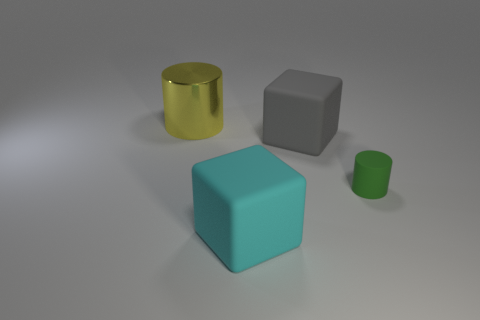Are any large gray rubber objects visible?
Your response must be concise. Yes. Do the large metallic object and the big object on the right side of the cyan object have the same shape?
Offer a very short reply. No. What color is the large matte block behind the block that is in front of the cylinder that is in front of the big cylinder?
Give a very brief answer. Gray. Are there any large yellow things in front of the gray block?
Your answer should be very brief. No. Is there another big thing made of the same material as the big gray thing?
Your answer should be compact. Yes. The metallic object is what color?
Provide a succinct answer. Yellow. There is a big matte object that is to the left of the large gray rubber thing; is its shape the same as the big gray object?
Your answer should be very brief. Yes. There is a thing that is on the left side of the large block that is on the left side of the rubber block behind the big cyan object; what is its shape?
Provide a short and direct response. Cylinder. What is the material of the cylinder on the right side of the yellow shiny cylinder?
Keep it short and to the point. Rubber. There is a metallic cylinder that is the same size as the cyan cube; what color is it?
Provide a succinct answer. Yellow. 